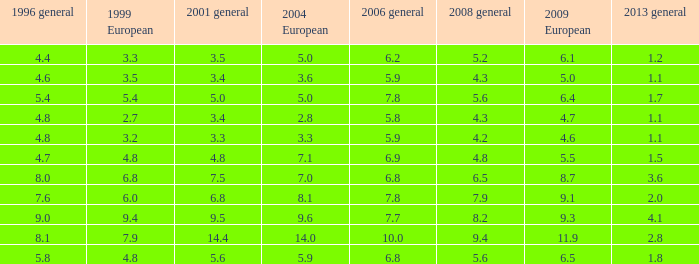Determine the average value of 2001 general, given that it exceeds 4.8 in 1999 european, 7.7 in 2006 general, and None. 